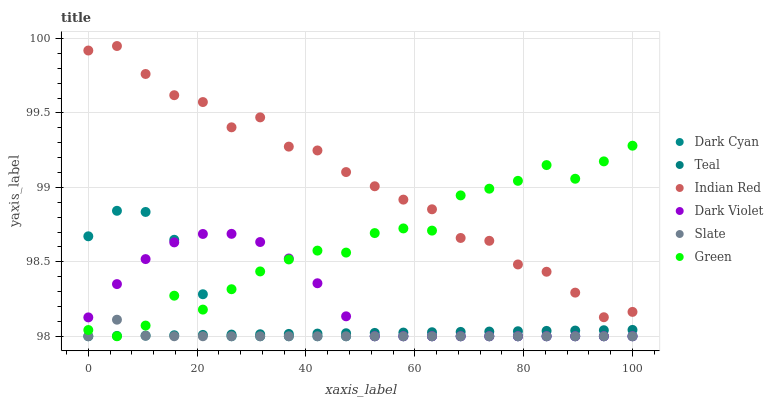Does Slate have the minimum area under the curve?
Answer yes or no. Yes. Does Indian Red have the maximum area under the curve?
Answer yes or no. Yes. Does Dark Violet have the minimum area under the curve?
Answer yes or no. No. Does Dark Violet have the maximum area under the curve?
Answer yes or no. No. Is Teal the smoothest?
Answer yes or no. Yes. Is Indian Red the roughest?
Answer yes or no. Yes. Is Slate the smoothest?
Answer yes or no. No. Is Slate the roughest?
Answer yes or no. No. Does Teal have the lowest value?
Answer yes or no. Yes. Does Indian Red have the lowest value?
Answer yes or no. No. Does Indian Red have the highest value?
Answer yes or no. Yes. Does Slate have the highest value?
Answer yes or no. No. Is Teal less than Indian Red?
Answer yes or no. Yes. Is Indian Red greater than Teal?
Answer yes or no. Yes. Does Indian Red intersect Green?
Answer yes or no. Yes. Is Indian Red less than Green?
Answer yes or no. No. Is Indian Red greater than Green?
Answer yes or no. No. Does Teal intersect Indian Red?
Answer yes or no. No. 